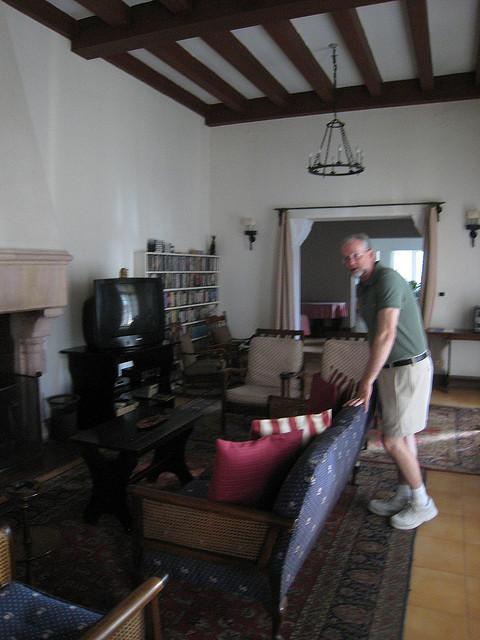Is there a fire in this picture?
Concise answer only. No. Which direction is the man facing?
Answer briefly. Left. What is the man on the right standing near?
Answer briefly. Couch. Is he young or old?
Give a very brief answer. Old. Is he a professional?
Concise answer only. No. What is he doing?
Keep it brief. Standing. Is there a television in this picture?
Write a very short answer. Yes. What is the man standing behind?
Short answer required. Couch. 